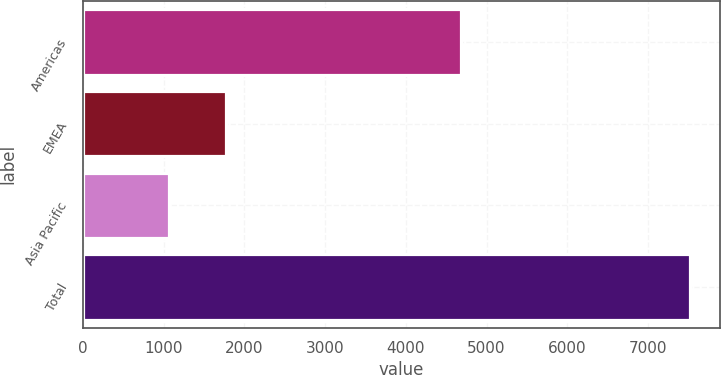Convert chart to OTSL. <chart><loc_0><loc_0><loc_500><loc_500><bar_chart><fcel>Americas<fcel>EMEA<fcel>Asia Pacific<fcel>Total<nl><fcel>4685.2<fcel>1767.9<fcel>1064.7<fcel>7517.8<nl></chart> 